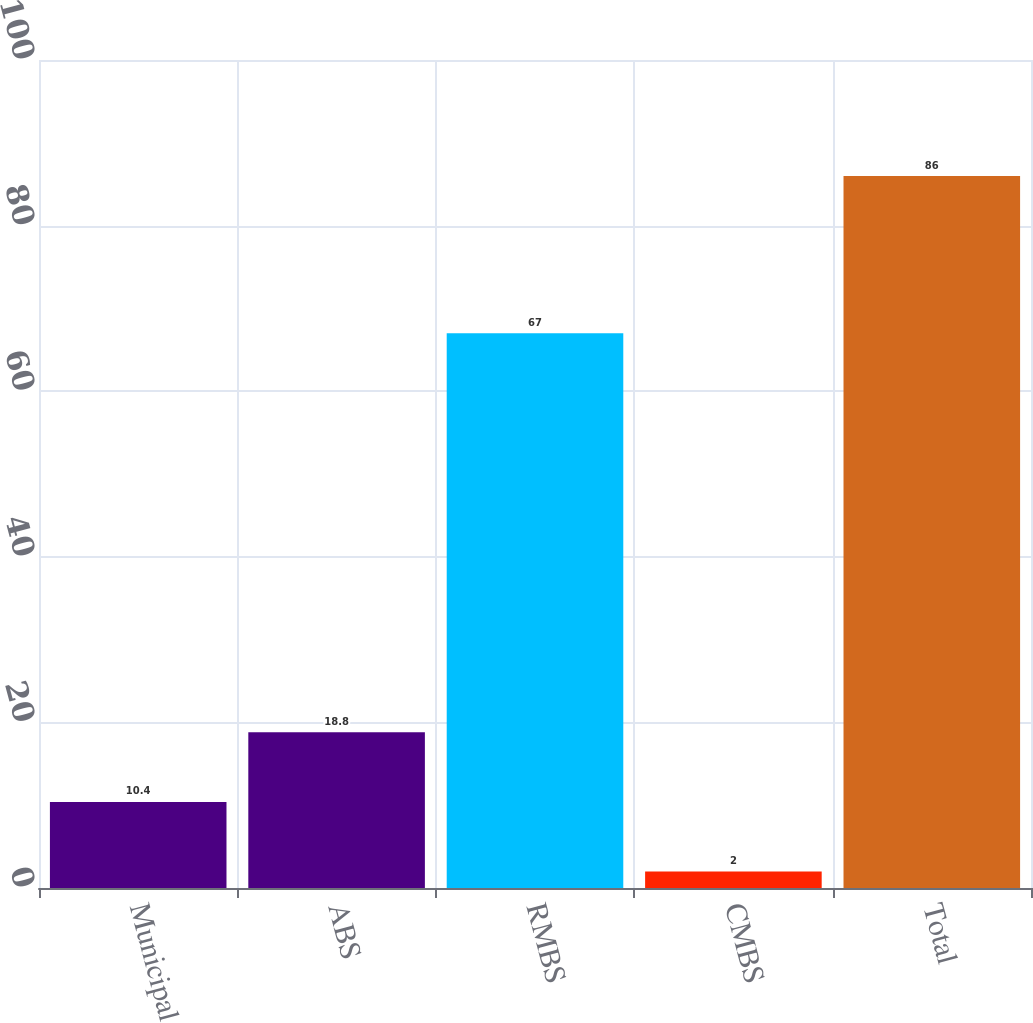Convert chart to OTSL. <chart><loc_0><loc_0><loc_500><loc_500><bar_chart><fcel>Municipal<fcel>ABS<fcel>RMBS<fcel>CMBS<fcel>Total<nl><fcel>10.4<fcel>18.8<fcel>67<fcel>2<fcel>86<nl></chart> 